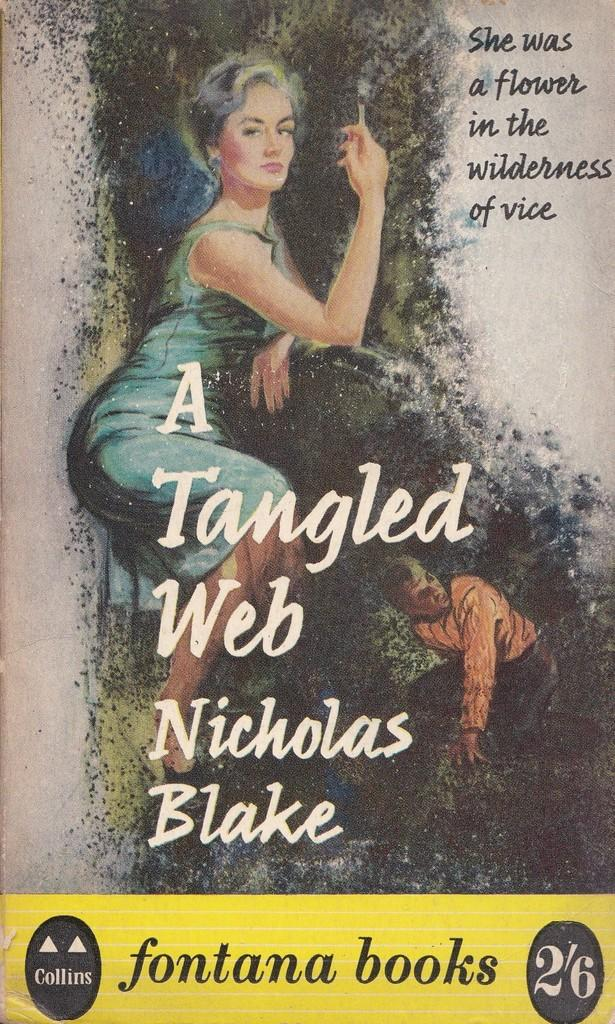<image>
Write a terse but informative summary of the picture. A fontana books book cover shows a woman in a dress. 